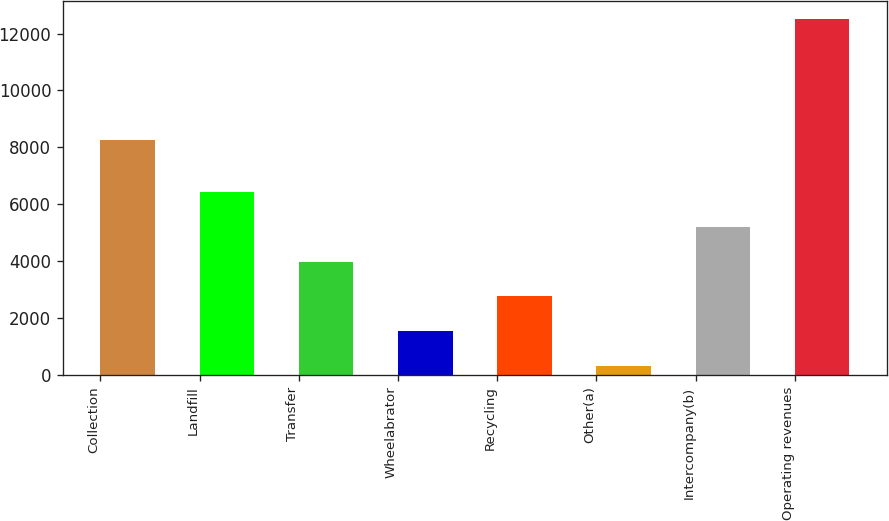<chart> <loc_0><loc_0><loc_500><loc_500><bar_chart><fcel>Collection<fcel>Landfill<fcel>Transfer<fcel>Wheelabrator<fcel>Recycling<fcel>Other(a)<fcel>Intercompany(b)<fcel>Operating revenues<nl><fcel>8247<fcel>6414.5<fcel>3974.3<fcel>1534.1<fcel>2754.2<fcel>314<fcel>5194.4<fcel>12515<nl></chart> 